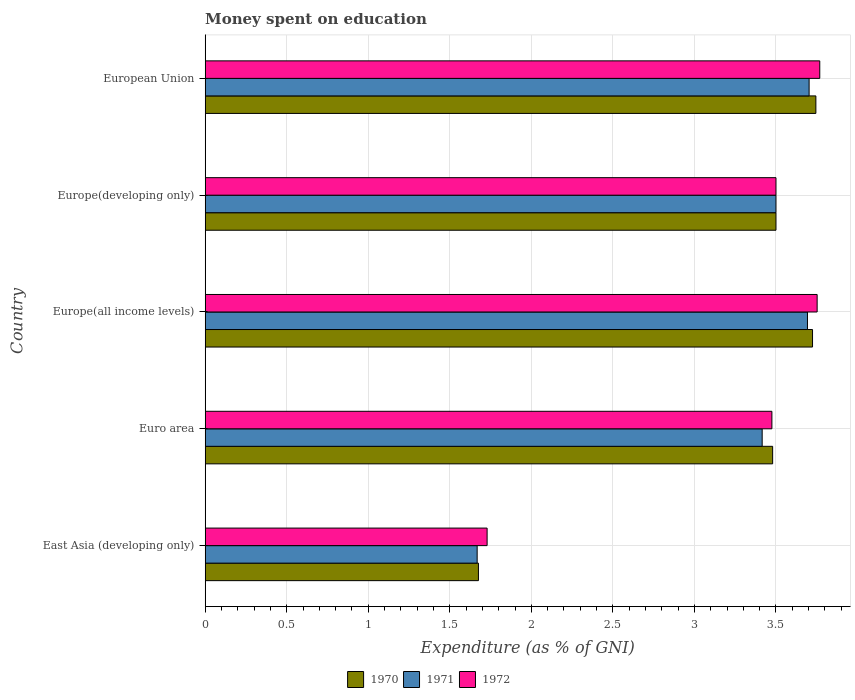How many groups of bars are there?
Provide a short and direct response. 5. Are the number of bars per tick equal to the number of legend labels?
Offer a very short reply. Yes. What is the label of the 5th group of bars from the top?
Ensure brevity in your answer.  East Asia (developing only). In how many cases, is the number of bars for a given country not equal to the number of legend labels?
Offer a very short reply. 0. What is the amount of money spent on education in 1972 in Europe(all income levels)?
Make the answer very short. 3.75. Across all countries, what is the maximum amount of money spent on education in 1972?
Offer a very short reply. 3.77. Across all countries, what is the minimum amount of money spent on education in 1970?
Offer a terse response. 1.68. In which country was the amount of money spent on education in 1972 minimum?
Make the answer very short. East Asia (developing only). What is the total amount of money spent on education in 1971 in the graph?
Your answer should be very brief. 15.98. What is the difference between the amount of money spent on education in 1971 in East Asia (developing only) and that in European Union?
Your answer should be compact. -2.04. What is the difference between the amount of money spent on education in 1970 in Europe(all income levels) and the amount of money spent on education in 1972 in East Asia (developing only)?
Your response must be concise. 2. What is the average amount of money spent on education in 1970 per country?
Your answer should be very brief. 3.22. What is the difference between the amount of money spent on education in 1972 and amount of money spent on education in 1970 in Europe(all income levels)?
Your answer should be compact. 0.03. What is the ratio of the amount of money spent on education in 1970 in Europe(developing only) to that in European Union?
Your answer should be compact. 0.93. Is the amount of money spent on education in 1971 in Euro area less than that in Europe(all income levels)?
Your answer should be compact. Yes. What is the difference between the highest and the second highest amount of money spent on education in 1970?
Ensure brevity in your answer.  0.02. What is the difference between the highest and the lowest amount of money spent on education in 1970?
Your response must be concise. 2.07. In how many countries, is the amount of money spent on education in 1970 greater than the average amount of money spent on education in 1970 taken over all countries?
Ensure brevity in your answer.  4. Is it the case that in every country, the sum of the amount of money spent on education in 1971 and amount of money spent on education in 1970 is greater than the amount of money spent on education in 1972?
Your answer should be very brief. Yes. How many bars are there?
Keep it short and to the point. 15. Are all the bars in the graph horizontal?
Your answer should be very brief. Yes. What is the difference between two consecutive major ticks on the X-axis?
Your answer should be compact. 0.5. Are the values on the major ticks of X-axis written in scientific E-notation?
Provide a succinct answer. No. Does the graph contain grids?
Make the answer very short. Yes. How many legend labels are there?
Your response must be concise. 3. How are the legend labels stacked?
Offer a terse response. Horizontal. What is the title of the graph?
Your answer should be compact. Money spent on education. What is the label or title of the X-axis?
Make the answer very short. Expenditure (as % of GNI). What is the label or title of the Y-axis?
Give a very brief answer. Country. What is the Expenditure (as % of GNI) of 1970 in East Asia (developing only)?
Make the answer very short. 1.68. What is the Expenditure (as % of GNI) in 1971 in East Asia (developing only)?
Your answer should be compact. 1.67. What is the Expenditure (as % of GNI) in 1972 in East Asia (developing only)?
Your answer should be very brief. 1.73. What is the Expenditure (as % of GNI) in 1970 in Euro area?
Ensure brevity in your answer.  3.48. What is the Expenditure (as % of GNI) of 1971 in Euro area?
Offer a terse response. 3.42. What is the Expenditure (as % of GNI) of 1972 in Euro area?
Ensure brevity in your answer.  3.47. What is the Expenditure (as % of GNI) in 1970 in Europe(all income levels)?
Your answer should be very brief. 3.72. What is the Expenditure (as % of GNI) in 1971 in Europe(all income levels)?
Your answer should be very brief. 3.69. What is the Expenditure (as % of GNI) of 1972 in Europe(all income levels)?
Provide a short and direct response. 3.75. What is the Expenditure (as % of GNI) in 1970 in Europe(developing only)?
Make the answer very short. 3.5. What is the Expenditure (as % of GNI) of 1970 in European Union?
Keep it short and to the point. 3.74. What is the Expenditure (as % of GNI) of 1971 in European Union?
Offer a terse response. 3.7. What is the Expenditure (as % of GNI) in 1972 in European Union?
Offer a very short reply. 3.77. Across all countries, what is the maximum Expenditure (as % of GNI) in 1970?
Offer a terse response. 3.74. Across all countries, what is the maximum Expenditure (as % of GNI) in 1971?
Your answer should be compact. 3.7. Across all countries, what is the maximum Expenditure (as % of GNI) in 1972?
Make the answer very short. 3.77. Across all countries, what is the minimum Expenditure (as % of GNI) in 1970?
Your answer should be very brief. 1.68. Across all countries, what is the minimum Expenditure (as % of GNI) in 1971?
Ensure brevity in your answer.  1.67. Across all countries, what is the minimum Expenditure (as % of GNI) in 1972?
Offer a terse response. 1.73. What is the total Expenditure (as % of GNI) in 1970 in the graph?
Your answer should be compact. 16.12. What is the total Expenditure (as % of GNI) in 1971 in the graph?
Offer a very short reply. 15.98. What is the total Expenditure (as % of GNI) in 1972 in the graph?
Offer a very short reply. 16.22. What is the difference between the Expenditure (as % of GNI) of 1970 in East Asia (developing only) and that in Euro area?
Offer a very short reply. -1.8. What is the difference between the Expenditure (as % of GNI) in 1971 in East Asia (developing only) and that in Euro area?
Your answer should be very brief. -1.75. What is the difference between the Expenditure (as % of GNI) of 1972 in East Asia (developing only) and that in Euro area?
Offer a very short reply. -1.75. What is the difference between the Expenditure (as % of GNI) in 1970 in East Asia (developing only) and that in Europe(all income levels)?
Make the answer very short. -2.05. What is the difference between the Expenditure (as % of GNI) in 1971 in East Asia (developing only) and that in Europe(all income levels)?
Offer a terse response. -2.03. What is the difference between the Expenditure (as % of GNI) in 1972 in East Asia (developing only) and that in Europe(all income levels)?
Offer a very short reply. -2.02. What is the difference between the Expenditure (as % of GNI) of 1970 in East Asia (developing only) and that in Europe(developing only)?
Your answer should be compact. -1.82. What is the difference between the Expenditure (as % of GNI) of 1971 in East Asia (developing only) and that in Europe(developing only)?
Your response must be concise. -1.83. What is the difference between the Expenditure (as % of GNI) of 1972 in East Asia (developing only) and that in Europe(developing only)?
Your response must be concise. -1.77. What is the difference between the Expenditure (as % of GNI) in 1970 in East Asia (developing only) and that in European Union?
Your answer should be very brief. -2.07. What is the difference between the Expenditure (as % of GNI) of 1971 in East Asia (developing only) and that in European Union?
Provide a succinct answer. -2.04. What is the difference between the Expenditure (as % of GNI) in 1972 in East Asia (developing only) and that in European Union?
Ensure brevity in your answer.  -2.04. What is the difference between the Expenditure (as % of GNI) in 1970 in Euro area and that in Europe(all income levels)?
Your answer should be compact. -0.24. What is the difference between the Expenditure (as % of GNI) of 1971 in Euro area and that in Europe(all income levels)?
Your response must be concise. -0.28. What is the difference between the Expenditure (as % of GNI) in 1972 in Euro area and that in Europe(all income levels)?
Provide a short and direct response. -0.28. What is the difference between the Expenditure (as % of GNI) in 1970 in Euro area and that in Europe(developing only)?
Ensure brevity in your answer.  -0.02. What is the difference between the Expenditure (as % of GNI) of 1971 in Euro area and that in Europe(developing only)?
Ensure brevity in your answer.  -0.08. What is the difference between the Expenditure (as % of GNI) of 1972 in Euro area and that in Europe(developing only)?
Your response must be concise. -0.03. What is the difference between the Expenditure (as % of GNI) of 1970 in Euro area and that in European Union?
Your answer should be compact. -0.27. What is the difference between the Expenditure (as % of GNI) of 1971 in Euro area and that in European Union?
Provide a succinct answer. -0.29. What is the difference between the Expenditure (as % of GNI) of 1972 in Euro area and that in European Union?
Your answer should be very brief. -0.29. What is the difference between the Expenditure (as % of GNI) in 1970 in Europe(all income levels) and that in Europe(developing only)?
Ensure brevity in your answer.  0.22. What is the difference between the Expenditure (as % of GNI) of 1971 in Europe(all income levels) and that in Europe(developing only)?
Give a very brief answer. 0.19. What is the difference between the Expenditure (as % of GNI) in 1972 in Europe(all income levels) and that in Europe(developing only)?
Offer a very short reply. 0.25. What is the difference between the Expenditure (as % of GNI) of 1970 in Europe(all income levels) and that in European Union?
Make the answer very short. -0.02. What is the difference between the Expenditure (as % of GNI) in 1971 in Europe(all income levels) and that in European Union?
Offer a very short reply. -0.01. What is the difference between the Expenditure (as % of GNI) in 1972 in Europe(all income levels) and that in European Union?
Your answer should be very brief. -0.02. What is the difference between the Expenditure (as % of GNI) in 1970 in Europe(developing only) and that in European Union?
Your response must be concise. -0.24. What is the difference between the Expenditure (as % of GNI) of 1971 in Europe(developing only) and that in European Union?
Give a very brief answer. -0.2. What is the difference between the Expenditure (as % of GNI) in 1972 in Europe(developing only) and that in European Union?
Offer a very short reply. -0.27. What is the difference between the Expenditure (as % of GNI) of 1970 in East Asia (developing only) and the Expenditure (as % of GNI) of 1971 in Euro area?
Your answer should be very brief. -1.74. What is the difference between the Expenditure (as % of GNI) of 1970 in East Asia (developing only) and the Expenditure (as % of GNI) of 1972 in Euro area?
Your response must be concise. -1.8. What is the difference between the Expenditure (as % of GNI) of 1971 in East Asia (developing only) and the Expenditure (as % of GNI) of 1972 in Euro area?
Your answer should be compact. -1.81. What is the difference between the Expenditure (as % of GNI) of 1970 in East Asia (developing only) and the Expenditure (as % of GNI) of 1971 in Europe(all income levels)?
Make the answer very short. -2.02. What is the difference between the Expenditure (as % of GNI) in 1970 in East Asia (developing only) and the Expenditure (as % of GNI) in 1972 in Europe(all income levels)?
Offer a very short reply. -2.08. What is the difference between the Expenditure (as % of GNI) of 1971 in East Asia (developing only) and the Expenditure (as % of GNI) of 1972 in Europe(all income levels)?
Your answer should be compact. -2.08. What is the difference between the Expenditure (as % of GNI) in 1970 in East Asia (developing only) and the Expenditure (as % of GNI) in 1971 in Europe(developing only)?
Your answer should be compact. -1.82. What is the difference between the Expenditure (as % of GNI) in 1970 in East Asia (developing only) and the Expenditure (as % of GNI) in 1972 in Europe(developing only)?
Your response must be concise. -1.82. What is the difference between the Expenditure (as % of GNI) in 1971 in East Asia (developing only) and the Expenditure (as % of GNI) in 1972 in Europe(developing only)?
Your response must be concise. -1.83. What is the difference between the Expenditure (as % of GNI) of 1970 in East Asia (developing only) and the Expenditure (as % of GNI) of 1971 in European Union?
Provide a short and direct response. -2.03. What is the difference between the Expenditure (as % of GNI) of 1970 in East Asia (developing only) and the Expenditure (as % of GNI) of 1972 in European Union?
Provide a short and direct response. -2.09. What is the difference between the Expenditure (as % of GNI) of 1971 in East Asia (developing only) and the Expenditure (as % of GNI) of 1972 in European Union?
Keep it short and to the point. -2.1. What is the difference between the Expenditure (as % of GNI) in 1970 in Euro area and the Expenditure (as % of GNI) in 1971 in Europe(all income levels)?
Provide a succinct answer. -0.21. What is the difference between the Expenditure (as % of GNI) in 1970 in Euro area and the Expenditure (as % of GNI) in 1972 in Europe(all income levels)?
Provide a succinct answer. -0.27. What is the difference between the Expenditure (as % of GNI) of 1971 in Euro area and the Expenditure (as % of GNI) of 1972 in Europe(all income levels)?
Provide a short and direct response. -0.34. What is the difference between the Expenditure (as % of GNI) of 1970 in Euro area and the Expenditure (as % of GNI) of 1971 in Europe(developing only)?
Offer a very short reply. -0.02. What is the difference between the Expenditure (as % of GNI) in 1970 in Euro area and the Expenditure (as % of GNI) in 1972 in Europe(developing only)?
Your response must be concise. -0.02. What is the difference between the Expenditure (as % of GNI) of 1971 in Euro area and the Expenditure (as % of GNI) of 1972 in Europe(developing only)?
Provide a succinct answer. -0.08. What is the difference between the Expenditure (as % of GNI) of 1970 in Euro area and the Expenditure (as % of GNI) of 1971 in European Union?
Your response must be concise. -0.22. What is the difference between the Expenditure (as % of GNI) in 1970 in Euro area and the Expenditure (as % of GNI) in 1972 in European Union?
Ensure brevity in your answer.  -0.29. What is the difference between the Expenditure (as % of GNI) in 1971 in Euro area and the Expenditure (as % of GNI) in 1972 in European Union?
Offer a terse response. -0.35. What is the difference between the Expenditure (as % of GNI) in 1970 in Europe(all income levels) and the Expenditure (as % of GNI) in 1971 in Europe(developing only)?
Ensure brevity in your answer.  0.22. What is the difference between the Expenditure (as % of GNI) of 1970 in Europe(all income levels) and the Expenditure (as % of GNI) of 1972 in Europe(developing only)?
Provide a succinct answer. 0.22. What is the difference between the Expenditure (as % of GNI) of 1971 in Europe(all income levels) and the Expenditure (as % of GNI) of 1972 in Europe(developing only)?
Offer a very short reply. 0.19. What is the difference between the Expenditure (as % of GNI) in 1970 in Europe(all income levels) and the Expenditure (as % of GNI) in 1971 in European Union?
Offer a very short reply. 0.02. What is the difference between the Expenditure (as % of GNI) of 1970 in Europe(all income levels) and the Expenditure (as % of GNI) of 1972 in European Union?
Give a very brief answer. -0.04. What is the difference between the Expenditure (as % of GNI) of 1971 in Europe(all income levels) and the Expenditure (as % of GNI) of 1972 in European Union?
Give a very brief answer. -0.08. What is the difference between the Expenditure (as % of GNI) of 1970 in Europe(developing only) and the Expenditure (as % of GNI) of 1971 in European Union?
Provide a succinct answer. -0.2. What is the difference between the Expenditure (as % of GNI) in 1970 in Europe(developing only) and the Expenditure (as % of GNI) in 1972 in European Union?
Offer a terse response. -0.27. What is the difference between the Expenditure (as % of GNI) of 1971 in Europe(developing only) and the Expenditure (as % of GNI) of 1972 in European Union?
Keep it short and to the point. -0.27. What is the average Expenditure (as % of GNI) of 1970 per country?
Your answer should be compact. 3.22. What is the average Expenditure (as % of GNI) of 1971 per country?
Your answer should be very brief. 3.2. What is the average Expenditure (as % of GNI) in 1972 per country?
Your answer should be compact. 3.24. What is the difference between the Expenditure (as % of GNI) of 1970 and Expenditure (as % of GNI) of 1971 in East Asia (developing only)?
Your answer should be very brief. 0.01. What is the difference between the Expenditure (as % of GNI) of 1970 and Expenditure (as % of GNI) of 1972 in East Asia (developing only)?
Your response must be concise. -0.05. What is the difference between the Expenditure (as % of GNI) in 1971 and Expenditure (as % of GNI) in 1972 in East Asia (developing only)?
Provide a short and direct response. -0.06. What is the difference between the Expenditure (as % of GNI) in 1970 and Expenditure (as % of GNI) in 1971 in Euro area?
Provide a succinct answer. 0.06. What is the difference between the Expenditure (as % of GNI) of 1970 and Expenditure (as % of GNI) of 1972 in Euro area?
Ensure brevity in your answer.  0. What is the difference between the Expenditure (as % of GNI) of 1971 and Expenditure (as % of GNI) of 1972 in Euro area?
Make the answer very short. -0.06. What is the difference between the Expenditure (as % of GNI) in 1970 and Expenditure (as % of GNI) in 1971 in Europe(all income levels)?
Provide a short and direct response. 0.03. What is the difference between the Expenditure (as % of GNI) in 1970 and Expenditure (as % of GNI) in 1972 in Europe(all income levels)?
Ensure brevity in your answer.  -0.03. What is the difference between the Expenditure (as % of GNI) in 1971 and Expenditure (as % of GNI) in 1972 in Europe(all income levels)?
Your answer should be compact. -0.06. What is the difference between the Expenditure (as % of GNI) of 1970 and Expenditure (as % of GNI) of 1972 in Europe(developing only)?
Offer a very short reply. 0. What is the difference between the Expenditure (as % of GNI) in 1970 and Expenditure (as % of GNI) in 1971 in European Union?
Your response must be concise. 0.04. What is the difference between the Expenditure (as % of GNI) in 1970 and Expenditure (as % of GNI) in 1972 in European Union?
Your answer should be compact. -0.02. What is the difference between the Expenditure (as % of GNI) in 1971 and Expenditure (as % of GNI) in 1972 in European Union?
Give a very brief answer. -0.07. What is the ratio of the Expenditure (as % of GNI) in 1970 in East Asia (developing only) to that in Euro area?
Offer a terse response. 0.48. What is the ratio of the Expenditure (as % of GNI) of 1971 in East Asia (developing only) to that in Euro area?
Keep it short and to the point. 0.49. What is the ratio of the Expenditure (as % of GNI) in 1972 in East Asia (developing only) to that in Euro area?
Provide a short and direct response. 0.5. What is the ratio of the Expenditure (as % of GNI) of 1970 in East Asia (developing only) to that in Europe(all income levels)?
Ensure brevity in your answer.  0.45. What is the ratio of the Expenditure (as % of GNI) in 1971 in East Asia (developing only) to that in Europe(all income levels)?
Your answer should be very brief. 0.45. What is the ratio of the Expenditure (as % of GNI) in 1972 in East Asia (developing only) to that in Europe(all income levels)?
Keep it short and to the point. 0.46. What is the ratio of the Expenditure (as % of GNI) of 1970 in East Asia (developing only) to that in Europe(developing only)?
Give a very brief answer. 0.48. What is the ratio of the Expenditure (as % of GNI) in 1971 in East Asia (developing only) to that in Europe(developing only)?
Provide a short and direct response. 0.48. What is the ratio of the Expenditure (as % of GNI) in 1972 in East Asia (developing only) to that in Europe(developing only)?
Make the answer very short. 0.49. What is the ratio of the Expenditure (as % of GNI) of 1970 in East Asia (developing only) to that in European Union?
Ensure brevity in your answer.  0.45. What is the ratio of the Expenditure (as % of GNI) in 1971 in East Asia (developing only) to that in European Union?
Provide a succinct answer. 0.45. What is the ratio of the Expenditure (as % of GNI) in 1972 in East Asia (developing only) to that in European Union?
Offer a very short reply. 0.46. What is the ratio of the Expenditure (as % of GNI) of 1970 in Euro area to that in Europe(all income levels)?
Keep it short and to the point. 0.93. What is the ratio of the Expenditure (as % of GNI) in 1971 in Euro area to that in Europe(all income levels)?
Make the answer very short. 0.92. What is the ratio of the Expenditure (as % of GNI) in 1972 in Euro area to that in Europe(all income levels)?
Offer a terse response. 0.93. What is the ratio of the Expenditure (as % of GNI) of 1970 in Euro area to that in Europe(developing only)?
Your answer should be compact. 0.99. What is the ratio of the Expenditure (as % of GNI) of 1971 in Euro area to that in Europe(developing only)?
Keep it short and to the point. 0.98. What is the ratio of the Expenditure (as % of GNI) of 1970 in Euro area to that in European Union?
Make the answer very short. 0.93. What is the ratio of the Expenditure (as % of GNI) in 1971 in Euro area to that in European Union?
Your answer should be very brief. 0.92. What is the ratio of the Expenditure (as % of GNI) of 1972 in Euro area to that in European Union?
Provide a succinct answer. 0.92. What is the ratio of the Expenditure (as % of GNI) in 1970 in Europe(all income levels) to that in Europe(developing only)?
Your answer should be very brief. 1.06. What is the ratio of the Expenditure (as % of GNI) in 1971 in Europe(all income levels) to that in Europe(developing only)?
Provide a short and direct response. 1.06. What is the ratio of the Expenditure (as % of GNI) of 1972 in Europe(all income levels) to that in Europe(developing only)?
Keep it short and to the point. 1.07. What is the ratio of the Expenditure (as % of GNI) in 1970 in Europe(all income levels) to that in European Union?
Provide a short and direct response. 0.99. What is the ratio of the Expenditure (as % of GNI) in 1970 in Europe(developing only) to that in European Union?
Your answer should be compact. 0.93. What is the ratio of the Expenditure (as % of GNI) of 1971 in Europe(developing only) to that in European Union?
Give a very brief answer. 0.95. What is the ratio of the Expenditure (as % of GNI) of 1972 in Europe(developing only) to that in European Union?
Provide a succinct answer. 0.93. What is the difference between the highest and the second highest Expenditure (as % of GNI) in 1970?
Your response must be concise. 0.02. What is the difference between the highest and the second highest Expenditure (as % of GNI) in 1971?
Offer a very short reply. 0.01. What is the difference between the highest and the second highest Expenditure (as % of GNI) in 1972?
Provide a succinct answer. 0.02. What is the difference between the highest and the lowest Expenditure (as % of GNI) in 1970?
Your answer should be compact. 2.07. What is the difference between the highest and the lowest Expenditure (as % of GNI) of 1971?
Your response must be concise. 2.04. What is the difference between the highest and the lowest Expenditure (as % of GNI) in 1972?
Provide a short and direct response. 2.04. 